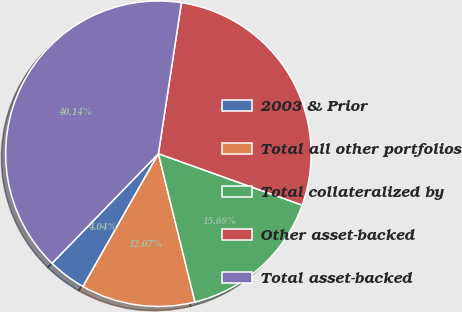Convert chart. <chart><loc_0><loc_0><loc_500><loc_500><pie_chart><fcel>2003 & Prior<fcel>Total all other portfolios<fcel>Total collateralized by<fcel>Other asset-backed<fcel>Total asset-backed<nl><fcel>4.04%<fcel>12.07%<fcel>15.68%<fcel>28.06%<fcel>40.14%<nl></chart> 